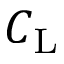<formula> <loc_0><loc_0><loc_500><loc_500>C _ { L }</formula> 